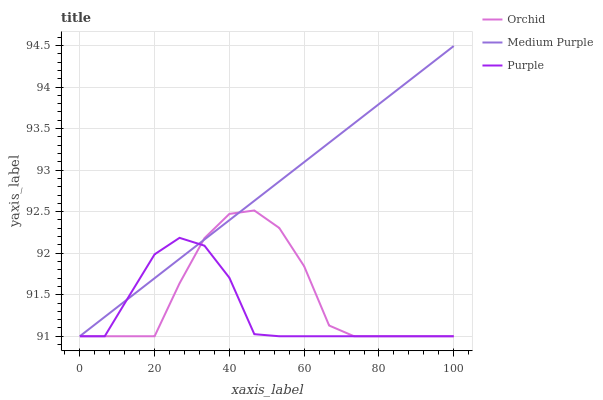Does Purple have the minimum area under the curve?
Answer yes or no. Yes. Does Medium Purple have the maximum area under the curve?
Answer yes or no. Yes. Does Orchid have the minimum area under the curve?
Answer yes or no. No. Does Orchid have the maximum area under the curve?
Answer yes or no. No. Is Medium Purple the smoothest?
Answer yes or no. Yes. Is Orchid the roughest?
Answer yes or no. Yes. Is Purple the smoothest?
Answer yes or no. No. Is Purple the roughest?
Answer yes or no. No. Does Medium Purple have the lowest value?
Answer yes or no. Yes. Does Medium Purple have the highest value?
Answer yes or no. Yes. Does Orchid have the highest value?
Answer yes or no. No. Does Orchid intersect Medium Purple?
Answer yes or no. Yes. Is Orchid less than Medium Purple?
Answer yes or no. No. Is Orchid greater than Medium Purple?
Answer yes or no. No. 